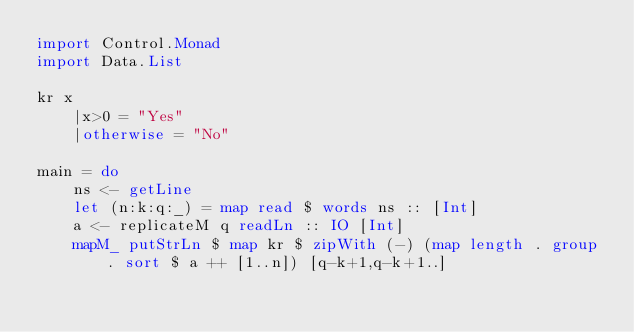Convert code to text. <code><loc_0><loc_0><loc_500><loc_500><_Haskell_>import Control.Monad
import Data.List

kr x
    |x>0 = "Yes"
    |otherwise = "No"

main = do
    ns <- getLine
    let (n:k:q:_) = map read $ words ns :: [Int]
    a <- replicateM q readLn :: IO [Int]
    mapM_ putStrLn $ map kr $ zipWith (-) (map length . group . sort $ a ++ [1..n]) [q-k+1,q-k+1..]
</code> 